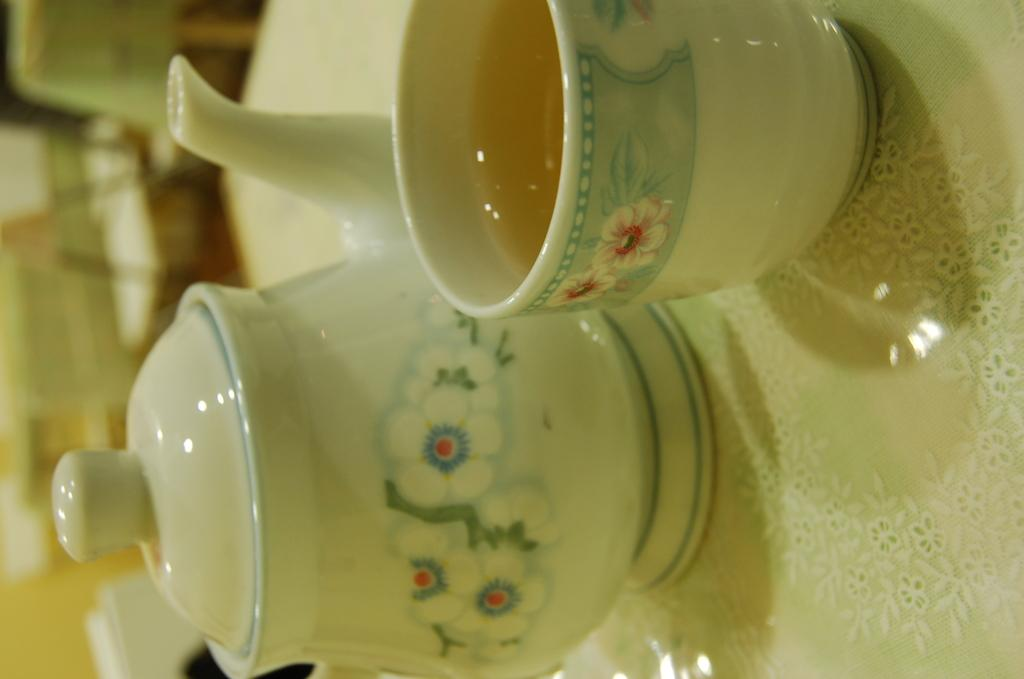What is in the cup that is visible in the image? There is a cup with liquid in the image. What other object is present in the image? There is a kettle with a lid in the image. What is the color of the surface on which the cup and kettle are placed? The cup and kettle are on a white surface. What can be seen on the left side of the image? There is a blurry view on the left side of the image. What type of business is being conducted in the cemetery in the image? There is no business being conducted in a cemetery in the image, nor is there any mention of a cemetery in the provided facts. 